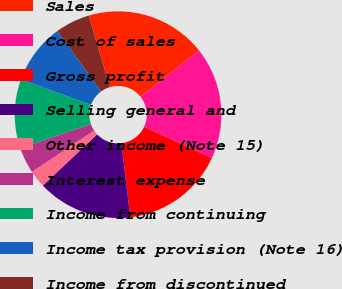<chart> <loc_0><loc_0><loc_500><loc_500><pie_chart><fcel>Sales<fcel>Cost of sales<fcel>Gross profit<fcel>Selling general and<fcel>Other income (Note 15)<fcel>Interest expense<fcel>Income from continuing<fcel>Income tax provision (Note 16)<fcel>Income from discontinued<nl><fcel>18.92%<fcel>17.57%<fcel>16.22%<fcel>14.86%<fcel>2.7%<fcel>4.06%<fcel>10.81%<fcel>9.46%<fcel>5.41%<nl></chart> 